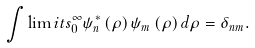Convert formula to latex. <formula><loc_0><loc_0><loc_500><loc_500>\int \lim i t s _ { 0 } ^ { \infty } { \psi _ { n } ^ { * } \left ( \rho \right ) \psi _ { m } \left ( \rho \right ) d \rho } = \delta _ { n m } .</formula> 